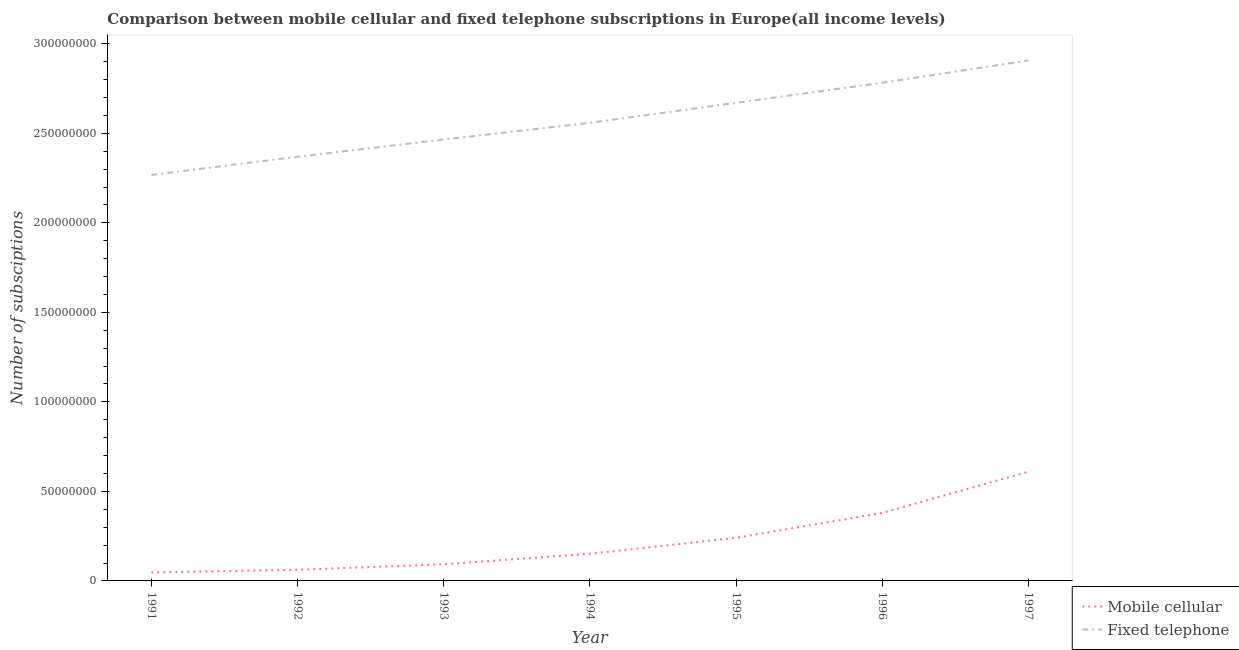Does the line corresponding to number of fixed telephone subscriptions intersect with the line corresponding to number of mobile cellular subscriptions?
Keep it short and to the point. No. What is the number of fixed telephone subscriptions in 1991?
Provide a short and direct response. 2.27e+08. Across all years, what is the maximum number of fixed telephone subscriptions?
Ensure brevity in your answer.  2.91e+08. Across all years, what is the minimum number of mobile cellular subscriptions?
Ensure brevity in your answer.  4.72e+06. In which year was the number of fixed telephone subscriptions maximum?
Offer a very short reply. 1997. In which year was the number of mobile cellular subscriptions minimum?
Your response must be concise. 1991. What is the total number of mobile cellular subscriptions in the graph?
Ensure brevity in your answer.  1.58e+08. What is the difference between the number of fixed telephone subscriptions in 1992 and that in 1996?
Make the answer very short. -4.13e+07. What is the difference between the number of fixed telephone subscriptions in 1994 and the number of mobile cellular subscriptions in 1996?
Offer a terse response. 2.18e+08. What is the average number of mobile cellular subscriptions per year?
Your response must be concise. 2.26e+07. In the year 1997, what is the difference between the number of fixed telephone subscriptions and number of mobile cellular subscriptions?
Provide a short and direct response. 2.30e+08. In how many years, is the number of fixed telephone subscriptions greater than 290000000?
Provide a succinct answer. 1. What is the ratio of the number of fixed telephone subscriptions in 1991 to that in 1997?
Keep it short and to the point. 0.78. Is the difference between the number of mobile cellular subscriptions in 1994 and 1995 greater than the difference between the number of fixed telephone subscriptions in 1994 and 1995?
Provide a short and direct response. Yes. What is the difference between the highest and the second highest number of mobile cellular subscriptions?
Offer a terse response. 2.30e+07. What is the difference between the highest and the lowest number of fixed telephone subscriptions?
Make the answer very short. 6.39e+07. Is the sum of the number of mobile cellular subscriptions in 1993 and 1994 greater than the maximum number of fixed telephone subscriptions across all years?
Offer a terse response. No. Does the number of mobile cellular subscriptions monotonically increase over the years?
Give a very brief answer. Yes. Is the number of mobile cellular subscriptions strictly greater than the number of fixed telephone subscriptions over the years?
Make the answer very short. No. Is the number of fixed telephone subscriptions strictly less than the number of mobile cellular subscriptions over the years?
Make the answer very short. No. How many years are there in the graph?
Keep it short and to the point. 7. Are the values on the major ticks of Y-axis written in scientific E-notation?
Your response must be concise. No. How many legend labels are there?
Offer a very short reply. 2. What is the title of the graph?
Your answer should be compact. Comparison between mobile cellular and fixed telephone subscriptions in Europe(all income levels). What is the label or title of the Y-axis?
Ensure brevity in your answer.  Number of subsciptions. What is the Number of subsciptions in Mobile cellular in 1991?
Make the answer very short. 4.72e+06. What is the Number of subsciptions in Fixed telephone in 1991?
Provide a succinct answer. 2.27e+08. What is the Number of subsciptions of Mobile cellular in 1992?
Make the answer very short. 6.25e+06. What is the Number of subsciptions in Fixed telephone in 1992?
Give a very brief answer. 2.37e+08. What is the Number of subsciptions in Mobile cellular in 1993?
Your answer should be very brief. 9.29e+06. What is the Number of subsciptions of Fixed telephone in 1993?
Your response must be concise. 2.47e+08. What is the Number of subsciptions of Mobile cellular in 1994?
Your answer should be very brief. 1.52e+07. What is the Number of subsciptions in Fixed telephone in 1994?
Your answer should be very brief. 2.56e+08. What is the Number of subsciptions of Mobile cellular in 1995?
Provide a succinct answer. 2.41e+07. What is the Number of subsciptions in Fixed telephone in 1995?
Offer a terse response. 2.67e+08. What is the Number of subsciptions in Mobile cellular in 1996?
Give a very brief answer. 3.80e+07. What is the Number of subsciptions in Fixed telephone in 1996?
Keep it short and to the point. 2.78e+08. What is the Number of subsciptions in Mobile cellular in 1997?
Provide a short and direct response. 6.10e+07. What is the Number of subsciptions of Fixed telephone in 1997?
Keep it short and to the point. 2.91e+08. Across all years, what is the maximum Number of subsciptions of Mobile cellular?
Make the answer very short. 6.10e+07. Across all years, what is the maximum Number of subsciptions of Fixed telephone?
Offer a very short reply. 2.91e+08. Across all years, what is the minimum Number of subsciptions of Mobile cellular?
Provide a succinct answer. 4.72e+06. Across all years, what is the minimum Number of subsciptions in Fixed telephone?
Your response must be concise. 2.27e+08. What is the total Number of subsciptions in Mobile cellular in the graph?
Provide a short and direct response. 1.58e+08. What is the total Number of subsciptions of Fixed telephone in the graph?
Ensure brevity in your answer.  1.80e+09. What is the difference between the Number of subsciptions in Mobile cellular in 1991 and that in 1992?
Provide a short and direct response. -1.53e+06. What is the difference between the Number of subsciptions in Fixed telephone in 1991 and that in 1992?
Your answer should be very brief. -1.02e+07. What is the difference between the Number of subsciptions in Mobile cellular in 1991 and that in 1993?
Your answer should be compact. -4.57e+06. What is the difference between the Number of subsciptions in Fixed telephone in 1991 and that in 1993?
Provide a short and direct response. -1.98e+07. What is the difference between the Number of subsciptions in Mobile cellular in 1991 and that in 1994?
Give a very brief answer. -1.04e+07. What is the difference between the Number of subsciptions of Fixed telephone in 1991 and that in 1994?
Ensure brevity in your answer.  -2.91e+07. What is the difference between the Number of subsciptions in Mobile cellular in 1991 and that in 1995?
Ensure brevity in your answer.  -1.94e+07. What is the difference between the Number of subsciptions of Fixed telephone in 1991 and that in 1995?
Your answer should be very brief. -4.03e+07. What is the difference between the Number of subsciptions of Mobile cellular in 1991 and that in 1996?
Ensure brevity in your answer.  -3.32e+07. What is the difference between the Number of subsciptions of Fixed telephone in 1991 and that in 1996?
Provide a succinct answer. -5.15e+07. What is the difference between the Number of subsciptions in Mobile cellular in 1991 and that in 1997?
Your answer should be very brief. -5.63e+07. What is the difference between the Number of subsciptions of Fixed telephone in 1991 and that in 1997?
Offer a terse response. -6.39e+07. What is the difference between the Number of subsciptions of Mobile cellular in 1992 and that in 1993?
Provide a succinct answer. -3.04e+06. What is the difference between the Number of subsciptions in Fixed telephone in 1992 and that in 1993?
Provide a succinct answer. -9.62e+06. What is the difference between the Number of subsciptions in Mobile cellular in 1992 and that in 1994?
Your answer should be compact. -8.90e+06. What is the difference between the Number of subsciptions of Fixed telephone in 1992 and that in 1994?
Your answer should be very brief. -1.89e+07. What is the difference between the Number of subsciptions in Mobile cellular in 1992 and that in 1995?
Provide a succinct answer. -1.78e+07. What is the difference between the Number of subsciptions of Fixed telephone in 1992 and that in 1995?
Offer a terse response. -3.01e+07. What is the difference between the Number of subsciptions of Mobile cellular in 1992 and that in 1996?
Make the answer very short. -3.17e+07. What is the difference between the Number of subsciptions in Fixed telephone in 1992 and that in 1996?
Offer a terse response. -4.13e+07. What is the difference between the Number of subsciptions of Mobile cellular in 1992 and that in 1997?
Your answer should be compact. -5.48e+07. What is the difference between the Number of subsciptions in Fixed telephone in 1992 and that in 1997?
Offer a very short reply. -5.38e+07. What is the difference between the Number of subsciptions of Mobile cellular in 1993 and that in 1994?
Your response must be concise. -5.86e+06. What is the difference between the Number of subsciptions of Fixed telephone in 1993 and that in 1994?
Your answer should be very brief. -9.32e+06. What is the difference between the Number of subsciptions of Mobile cellular in 1993 and that in 1995?
Give a very brief answer. -1.48e+07. What is the difference between the Number of subsciptions in Fixed telephone in 1993 and that in 1995?
Ensure brevity in your answer.  -2.05e+07. What is the difference between the Number of subsciptions in Mobile cellular in 1993 and that in 1996?
Provide a short and direct response. -2.87e+07. What is the difference between the Number of subsciptions in Fixed telephone in 1993 and that in 1996?
Give a very brief answer. -3.17e+07. What is the difference between the Number of subsciptions in Mobile cellular in 1993 and that in 1997?
Offer a very short reply. -5.17e+07. What is the difference between the Number of subsciptions in Fixed telephone in 1993 and that in 1997?
Give a very brief answer. -4.42e+07. What is the difference between the Number of subsciptions in Mobile cellular in 1994 and that in 1995?
Your response must be concise. -8.93e+06. What is the difference between the Number of subsciptions in Fixed telephone in 1994 and that in 1995?
Provide a succinct answer. -1.12e+07. What is the difference between the Number of subsciptions in Mobile cellular in 1994 and that in 1996?
Offer a very short reply. -2.28e+07. What is the difference between the Number of subsciptions in Fixed telephone in 1994 and that in 1996?
Offer a very short reply. -2.24e+07. What is the difference between the Number of subsciptions of Mobile cellular in 1994 and that in 1997?
Provide a short and direct response. -4.59e+07. What is the difference between the Number of subsciptions in Fixed telephone in 1994 and that in 1997?
Make the answer very short. -3.48e+07. What is the difference between the Number of subsciptions of Mobile cellular in 1995 and that in 1996?
Offer a terse response. -1.39e+07. What is the difference between the Number of subsciptions in Fixed telephone in 1995 and that in 1996?
Keep it short and to the point. -1.12e+07. What is the difference between the Number of subsciptions in Mobile cellular in 1995 and that in 1997?
Give a very brief answer. -3.69e+07. What is the difference between the Number of subsciptions in Fixed telephone in 1995 and that in 1997?
Provide a short and direct response. -2.36e+07. What is the difference between the Number of subsciptions in Mobile cellular in 1996 and that in 1997?
Give a very brief answer. -2.30e+07. What is the difference between the Number of subsciptions of Fixed telephone in 1996 and that in 1997?
Keep it short and to the point. -1.24e+07. What is the difference between the Number of subsciptions in Mobile cellular in 1991 and the Number of subsciptions in Fixed telephone in 1992?
Your answer should be compact. -2.32e+08. What is the difference between the Number of subsciptions in Mobile cellular in 1991 and the Number of subsciptions in Fixed telephone in 1993?
Keep it short and to the point. -2.42e+08. What is the difference between the Number of subsciptions of Mobile cellular in 1991 and the Number of subsciptions of Fixed telephone in 1994?
Give a very brief answer. -2.51e+08. What is the difference between the Number of subsciptions of Mobile cellular in 1991 and the Number of subsciptions of Fixed telephone in 1995?
Your answer should be compact. -2.62e+08. What is the difference between the Number of subsciptions of Mobile cellular in 1991 and the Number of subsciptions of Fixed telephone in 1996?
Make the answer very short. -2.74e+08. What is the difference between the Number of subsciptions in Mobile cellular in 1991 and the Number of subsciptions in Fixed telephone in 1997?
Your answer should be very brief. -2.86e+08. What is the difference between the Number of subsciptions of Mobile cellular in 1992 and the Number of subsciptions of Fixed telephone in 1993?
Your answer should be very brief. -2.40e+08. What is the difference between the Number of subsciptions of Mobile cellular in 1992 and the Number of subsciptions of Fixed telephone in 1994?
Your answer should be compact. -2.50e+08. What is the difference between the Number of subsciptions of Mobile cellular in 1992 and the Number of subsciptions of Fixed telephone in 1995?
Ensure brevity in your answer.  -2.61e+08. What is the difference between the Number of subsciptions of Mobile cellular in 1992 and the Number of subsciptions of Fixed telephone in 1996?
Your answer should be very brief. -2.72e+08. What is the difference between the Number of subsciptions of Mobile cellular in 1992 and the Number of subsciptions of Fixed telephone in 1997?
Provide a succinct answer. -2.84e+08. What is the difference between the Number of subsciptions of Mobile cellular in 1993 and the Number of subsciptions of Fixed telephone in 1994?
Make the answer very short. -2.47e+08. What is the difference between the Number of subsciptions of Mobile cellular in 1993 and the Number of subsciptions of Fixed telephone in 1995?
Make the answer very short. -2.58e+08. What is the difference between the Number of subsciptions in Mobile cellular in 1993 and the Number of subsciptions in Fixed telephone in 1996?
Offer a terse response. -2.69e+08. What is the difference between the Number of subsciptions of Mobile cellular in 1993 and the Number of subsciptions of Fixed telephone in 1997?
Your response must be concise. -2.81e+08. What is the difference between the Number of subsciptions of Mobile cellular in 1994 and the Number of subsciptions of Fixed telephone in 1995?
Provide a succinct answer. -2.52e+08. What is the difference between the Number of subsciptions of Mobile cellular in 1994 and the Number of subsciptions of Fixed telephone in 1996?
Your response must be concise. -2.63e+08. What is the difference between the Number of subsciptions of Mobile cellular in 1994 and the Number of subsciptions of Fixed telephone in 1997?
Provide a short and direct response. -2.76e+08. What is the difference between the Number of subsciptions in Mobile cellular in 1995 and the Number of subsciptions in Fixed telephone in 1996?
Offer a terse response. -2.54e+08. What is the difference between the Number of subsciptions in Mobile cellular in 1995 and the Number of subsciptions in Fixed telephone in 1997?
Keep it short and to the point. -2.67e+08. What is the difference between the Number of subsciptions in Mobile cellular in 1996 and the Number of subsciptions in Fixed telephone in 1997?
Your response must be concise. -2.53e+08. What is the average Number of subsciptions in Mobile cellular per year?
Provide a succinct answer. 2.26e+07. What is the average Number of subsciptions in Fixed telephone per year?
Provide a short and direct response. 2.57e+08. In the year 1991, what is the difference between the Number of subsciptions in Mobile cellular and Number of subsciptions in Fixed telephone?
Your answer should be very brief. -2.22e+08. In the year 1992, what is the difference between the Number of subsciptions of Mobile cellular and Number of subsciptions of Fixed telephone?
Your response must be concise. -2.31e+08. In the year 1993, what is the difference between the Number of subsciptions in Mobile cellular and Number of subsciptions in Fixed telephone?
Your answer should be very brief. -2.37e+08. In the year 1994, what is the difference between the Number of subsciptions of Mobile cellular and Number of subsciptions of Fixed telephone?
Your response must be concise. -2.41e+08. In the year 1995, what is the difference between the Number of subsciptions in Mobile cellular and Number of subsciptions in Fixed telephone?
Ensure brevity in your answer.  -2.43e+08. In the year 1996, what is the difference between the Number of subsciptions of Mobile cellular and Number of subsciptions of Fixed telephone?
Give a very brief answer. -2.40e+08. In the year 1997, what is the difference between the Number of subsciptions in Mobile cellular and Number of subsciptions in Fixed telephone?
Keep it short and to the point. -2.30e+08. What is the ratio of the Number of subsciptions in Mobile cellular in 1991 to that in 1992?
Offer a very short reply. 0.76. What is the ratio of the Number of subsciptions of Fixed telephone in 1991 to that in 1992?
Make the answer very short. 0.96. What is the ratio of the Number of subsciptions of Mobile cellular in 1991 to that in 1993?
Offer a terse response. 0.51. What is the ratio of the Number of subsciptions of Fixed telephone in 1991 to that in 1993?
Give a very brief answer. 0.92. What is the ratio of the Number of subsciptions in Mobile cellular in 1991 to that in 1994?
Make the answer very short. 0.31. What is the ratio of the Number of subsciptions in Fixed telephone in 1991 to that in 1994?
Provide a short and direct response. 0.89. What is the ratio of the Number of subsciptions of Mobile cellular in 1991 to that in 1995?
Provide a short and direct response. 0.2. What is the ratio of the Number of subsciptions in Fixed telephone in 1991 to that in 1995?
Provide a succinct answer. 0.85. What is the ratio of the Number of subsciptions of Mobile cellular in 1991 to that in 1996?
Provide a short and direct response. 0.12. What is the ratio of the Number of subsciptions of Fixed telephone in 1991 to that in 1996?
Offer a terse response. 0.81. What is the ratio of the Number of subsciptions in Mobile cellular in 1991 to that in 1997?
Your answer should be very brief. 0.08. What is the ratio of the Number of subsciptions of Fixed telephone in 1991 to that in 1997?
Your answer should be compact. 0.78. What is the ratio of the Number of subsciptions in Mobile cellular in 1992 to that in 1993?
Your response must be concise. 0.67. What is the ratio of the Number of subsciptions of Mobile cellular in 1992 to that in 1994?
Ensure brevity in your answer.  0.41. What is the ratio of the Number of subsciptions in Fixed telephone in 1992 to that in 1994?
Make the answer very short. 0.93. What is the ratio of the Number of subsciptions of Mobile cellular in 1992 to that in 1995?
Your response must be concise. 0.26. What is the ratio of the Number of subsciptions of Fixed telephone in 1992 to that in 1995?
Your answer should be very brief. 0.89. What is the ratio of the Number of subsciptions in Mobile cellular in 1992 to that in 1996?
Provide a succinct answer. 0.16. What is the ratio of the Number of subsciptions of Fixed telephone in 1992 to that in 1996?
Provide a short and direct response. 0.85. What is the ratio of the Number of subsciptions in Mobile cellular in 1992 to that in 1997?
Your response must be concise. 0.1. What is the ratio of the Number of subsciptions in Fixed telephone in 1992 to that in 1997?
Provide a short and direct response. 0.81. What is the ratio of the Number of subsciptions in Mobile cellular in 1993 to that in 1994?
Offer a very short reply. 0.61. What is the ratio of the Number of subsciptions in Fixed telephone in 1993 to that in 1994?
Keep it short and to the point. 0.96. What is the ratio of the Number of subsciptions of Mobile cellular in 1993 to that in 1995?
Make the answer very short. 0.39. What is the ratio of the Number of subsciptions in Fixed telephone in 1993 to that in 1995?
Offer a very short reply. 0.92. What is the ratio of the Number of subsciptions in Mobile cellular in 1993 to that in 1996?
Offer a very short reply. 0.24. What is the ratio of the Number of subsciptions of Fixed telephone in 1993 to that in 1996?
Your answer should be compact. 0.89. What is the ratio of the Number of subsciptions of Mobile cellular in 1993 to that in 1997?
Ensure brevity in your answer.  0.15. What is the ratio of the Number of subsciptions in Fixed telephone in 1993 to that in 1997?
Make the answer very short. 0.85. What is the ratio of the Number of subsciptions of Mobile cellular in 1994 to that in 1995?
Provide a short and direct response. 0.63. What is the ratio of the Number of subsciptions in Fixed telephone in 1994 to that in 1995?
Your answer should be very brief. 0.96. What is the ratio of the Number of subsciptions of Mobile cellular in 1994 to that in 1996?
Your answer should be very brief. 0.4. What is the ratio of the Number of subsciptions in Fixed telephone in 1994 to that in 1996?
Offer a very short reply. 0.92. What is the ratio of the Number of subsciptions in Mobile cellular in 1994 to that in 1997?
Your response must be concise. 0.25. What is the ratio of the Number of subsciptions in Fixed telephone in 1994 to that in 1997?
Your response must be concise. 0.88. What is the ratio of the Number of subsciptions in Mobile cellular in 1995 to that in 1996?
Give a very brief answer. 0.63. What is the ratio of the Number of subsciptions in Fixed telephone in 1995 to that in 1996?
Keep it short and to the point. 0.96. What is the ratio of the Number of subsciptions of Mobile cellular in 1995 to that in 1997?
Your answer should be compact. 0.39. What is the ratio of the Number of subsciptions of Fixed telephone in 1995 to that in 1997?
Offer a very short reply. 0.92. What is the ratio of the Number of subsciptions in Mobile cellular in 1996 to that in 1997?
Keep it short and to the point. 0.62. What is the ratio of the Number of subsciptions of Fixed telephone in 1996 to that in 1997?
Offer a very short reply. 0.96. What is the difference between the highest and the second highest Number of subsciptions of Mobile cellular?
Provide a succinct answer. 2.30e+07. What is the difference between the highest and the second highest Number of subsciptions of Fixed telephone?
Provide a short and direct response. 1.24e+07. What is the difference between the highest and the lowest Number of subsciptions of Mobile cellular?
Provide a short and direct response. 5.63e+07. What is the difference between the highest and the lowest Number of subsciptions in Fixed telephone?
Your answer should be compact. 6.39e+07. 